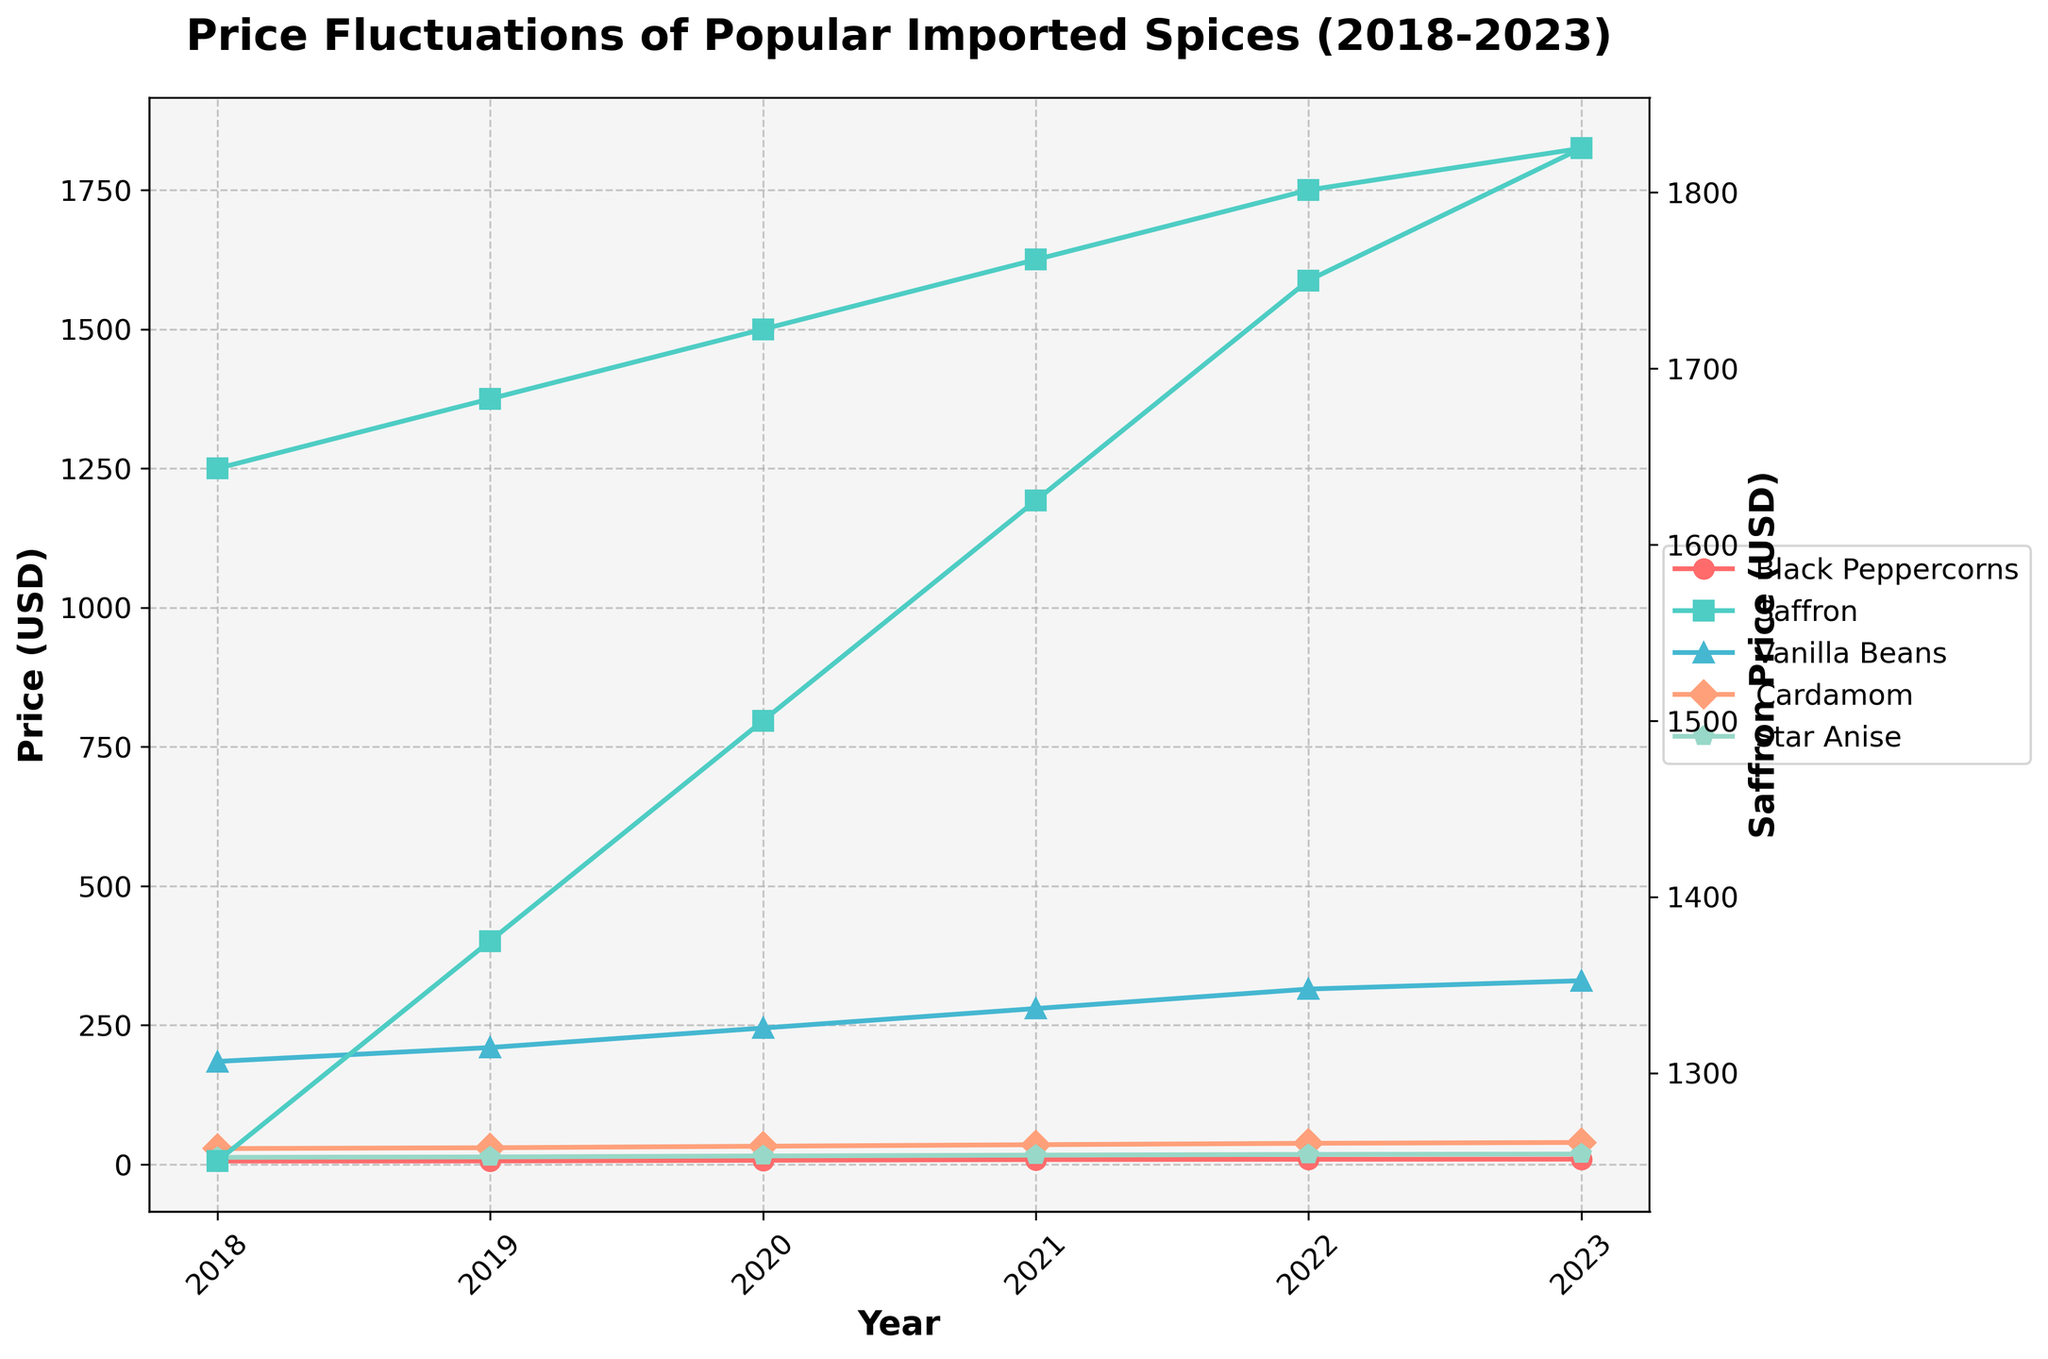What was the price difference of Saffron between 2023 and 2018? To find the difference, subtract the 2018 price from the 2023 price: 1825.00 - 1250.00 = 575.00.
Answer: 575.00 Which spice had the highest price in 2023? Among the prices listed for 2023, Vanilla Beans had the highest price of 330.00, which is less than the price of Saffron, which was 1825.00. Hence, Saffron had the highest price.
Answer: Saffron How did the price of Black Peppercorns change from 2018 to 2023? The price of Black Peppercorns in 2018 was 5.99, and in 2023 it was 9.50. So the change is calculated by subtracting the 2018 price from the 2023 price: 9.50 - 5.99 = 3.51.
Answer: Increased by 3.51 What was the average price of Vanilla Beans over 5 years? Sum up the prices of Vanilla Beans from 2018 to 2023 and divide by the number of years: (185 + 210 + 245 + 280 + 315 + 330) / 6 = 244.17.
Answer: 244.17 How does the price trend of Star Anise compare visually to that of Black Peppercorns over the 5 years? Observing the lines, both show a continuous increase. Black Peppercorns' increase is steeper compared to that of Star Anise.
Answer: Both increase, Black Peppercorns steeper 